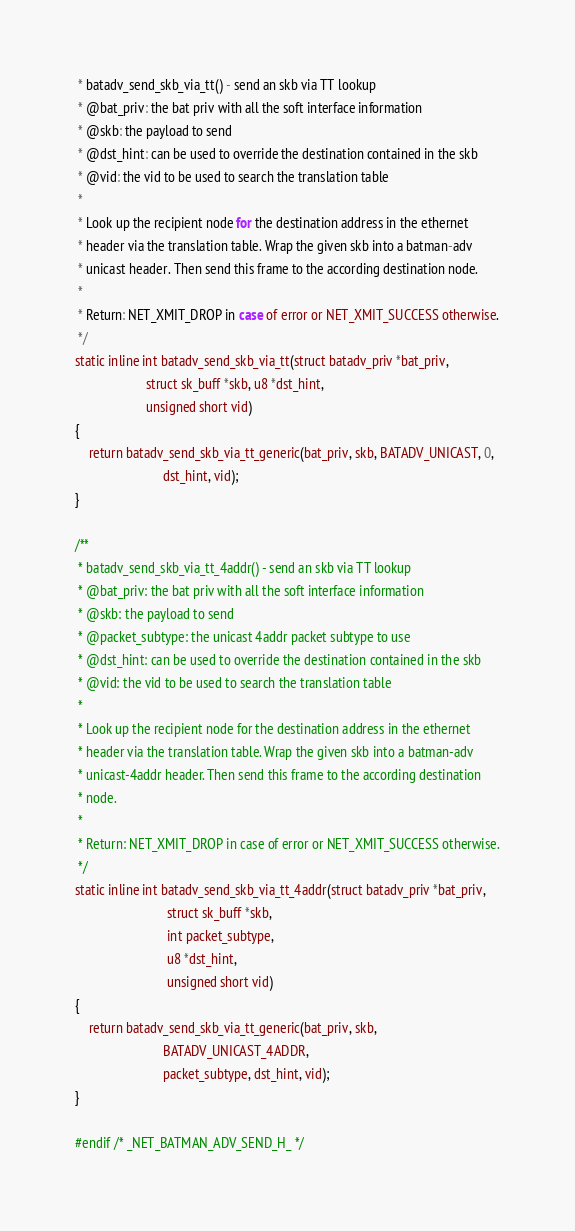<code> <loc_0><loc_0><loc_500><loc_500><_C_> * batadv_send_skb_via_tt() - send an skb via TT lookup
 * @bat_priv: the bat priv with all the soft interface information
 * @skb: the payload to send
 * @dst_hint: can be used to override the destination contained in the skb
 * @vid: the vid to be used to search the translation table
 *
 * Look up the recipient node for the destination address in the ethernet
 * header via the translation table. Wrap the given skb into a batman-adv
 * unicast header. Then send this frame to the according destination node.
 *
 * Return: NET_XMIT_DROP in case of error or NET_XMIT_SUCCESS otherwise.
 */
static inline int batadv_send_skb_via_tt(struct batadv_priv *bat_priv,
					 struct sk_buff *skb, u8 *dst_hint,
					 unsigned short vid)
{
	return batadv_send_skb_via_tt_generic(bat_priv, skb, BATADV_UNICAST, 0,
					      dst_hint, vid);
}

/**
 * batadv_send_skb_via_tt_4addr() - send an skb via TT lookup
 * @bat_priv: the bat priv with all the soft interface information
 * @skb: the payload to send
 * @packet_subtype: the unicast 4addr packet subtype to use
 * @dst_hint: can be used to override the destination contained in the skb
 * @vid: the vid to be used to search the translation table
 *
 * Look up the recipient node for the destination address in the ethernet
 * header via the translation table. Wrap the given skb into a batman-adv
 * unicast-4addr header. Then send this frame to the according destination
 * node.
 *
 * Return: NET_XMIT_DROP in case of error or NET_XMIT_SUCCESS otherwise.
 */
static inline int batadv_send_skb_via_tt_4addr(struct batadv_priv *bat_priv,
					       struct sk_buff *skb,
					       int packet_subtype,
					       u8 *dst_hint,
					       unsigned short vid)
{
	return batadv_send_skb_via_tt_generic(bat_priv, skb,
					      BATADV_UNICAST_4ADDR,
					      packet_subtype, dst_hint, vid);
}

#endif /* _NET_BATMAN_ADV_SEND_H_ */
</code> 